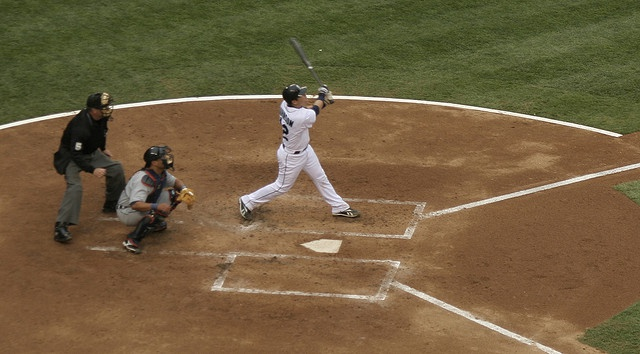Describe the objects in this image and their specific colors. I can see people in darkgreen, darkgray, lavender, and gray tones, people in darkgreen, black, and gray tones, people in darkgreen, black, gray, darkgray, and maroon tones, baseball glove in darkgreen, olive, gray, maroon, and black tones, and baseball bat in darkgreen, gray, and black tones in this image. 